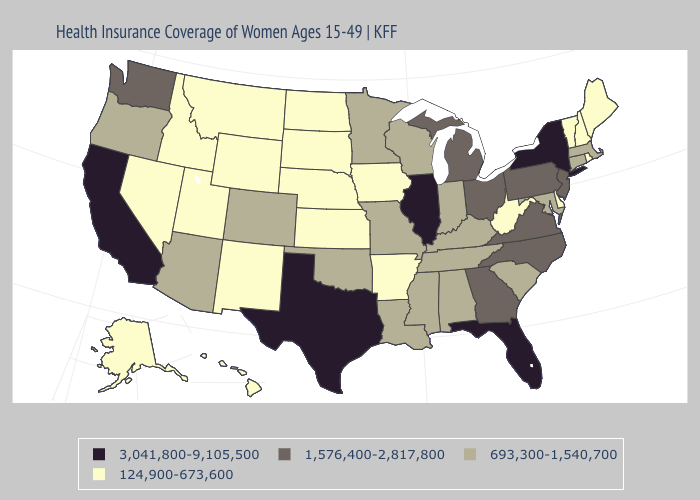What is the highest value in the USA?
Give a very brief answer. 3,041,800-9,105,500. Name the states that have a value in the range 124,900-673,600?
Keep it brief. Alaska, Arkansas, Delaware, Hawaii, Idaho, Iowa, Kansas, Maine, Montana, Nebraska, Nevada, New Hampshire, New Mexico, North Dakota, Rhode Island, South Dakota, Utah, Vermont, West Virginia, Wyoming. Does Ohio have the highest value in the MidWest?
Keep it brief. No. Name the states that have a value in the range 3,041,800-9,105,500?
Give a very brief answer. California, Florida, Illinois, New York, Texas. What is the value of California?
Be succinct. 3,041,800-9,105,500. Among the states that border Kansas , which have the highest value?
Keep it brief. Colorado, Missouri, Oklahoma. What is the value of New Hampshire?
Keep it brief. 124,900-673,600. How many symbols are there in the legend?
Give a very brief answer. 4. Which states have the lowest value in the MidWest?
Answer briefly. Iowa, Kansas, Nebraska, North Dakota, South Dakota. How many symbols are there in the legend?
Concise answer only. 4. Does New York have the highest value in the Northeast?
Keep it brief. Yes. Name the states that have a value in the range 124,900-673,600?
Concise answer only. Alaska, Arkansas, Delaware, Hawaii, Idaho, Iowa, Kansas, Maine, Montana, Nebraska, Nevada, New Hampshire, New Mexico, North Dakota, Rhode Island, South Dakota, Utah, Vermont, West Virginia, Wyoming. Name the states that have a value in the range 1,576,400-2,817,800?
Be succinct. Georgia, Michigan, New Jersey, North Carolina, Ohio, Pennsylvania, Virginia, Washington. What is the value of Connecticut?
Concise answer only. 693,300-1,540,700. What is the lowest value in the West?
Quick response, please. 124,900-673,600. 